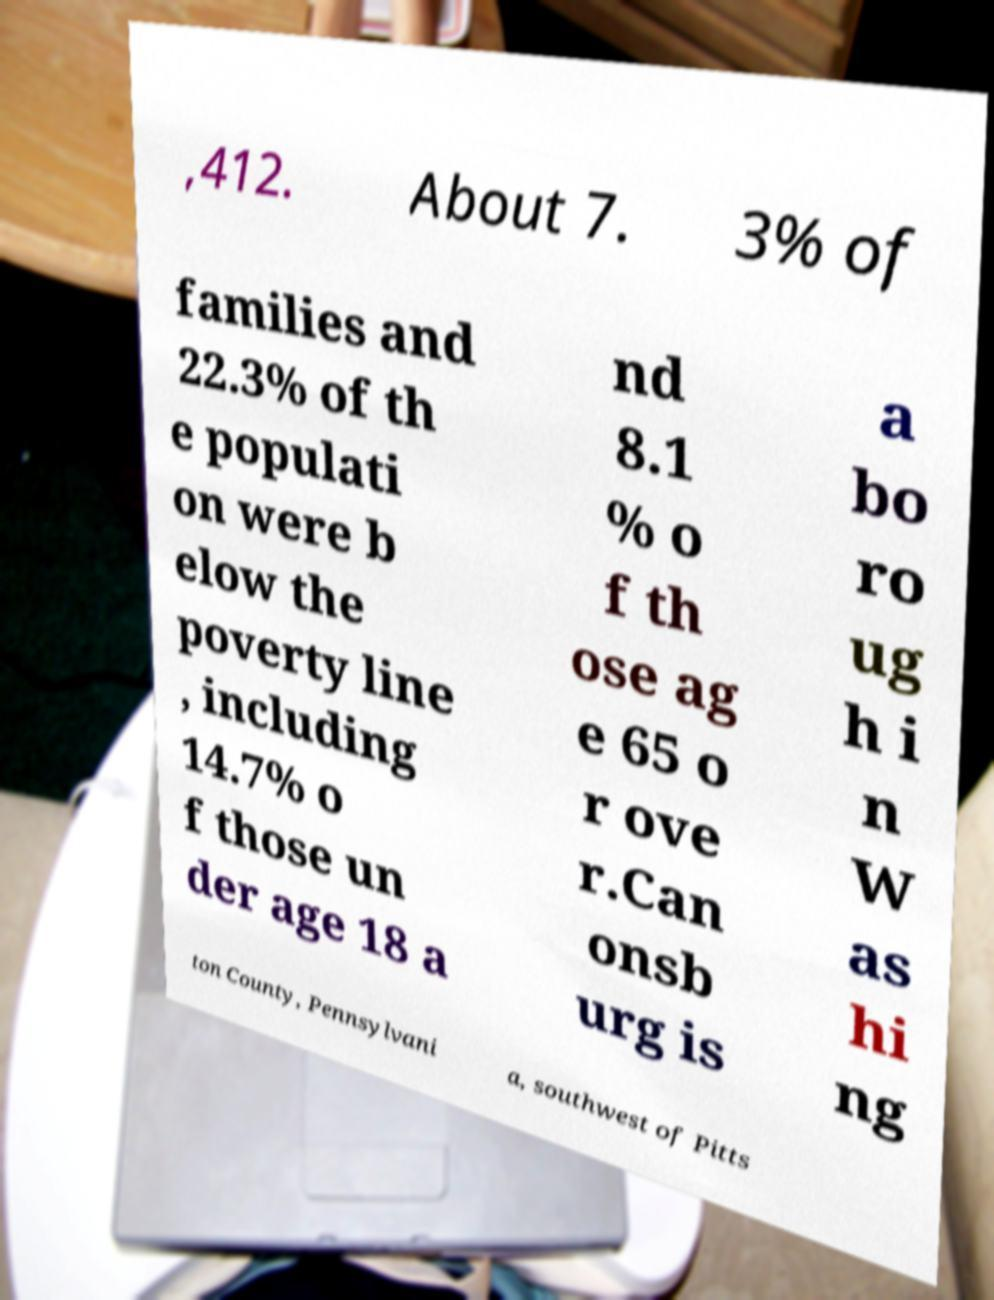What messages or text are displayed in this image? I need them in a readable, typed format. ,412. About 7. 3% of families and 22.3% of th e populati on were b elow the poverty line , including 14.7% o f those un der age 18 a nd 8.1 % o f th ose ag e 65 o r ove r.Can onsb urg is a bo ro ug h i n W as hi ng ton County, Pennsylvani a, southwest of Pitts 